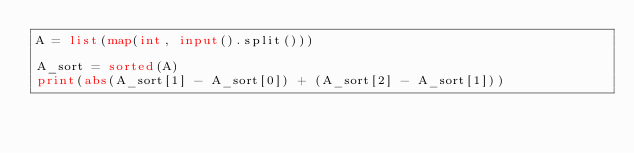Convert code to text. <code><loc_0><loc_0><loc_500><loc_500><_Python_>A = list(map(int, input().split()))

A_sort = sorted(A)
print(abs(A_sort[1] - A_sort[0]) + (A_sort[2] - A_sort[1]))</code> 